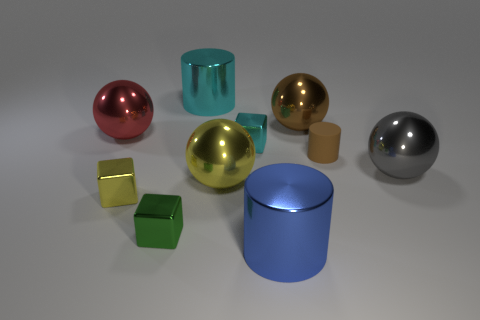Subtract all cyan metal cylinders. How many cylinders are left? 2 Subtract all green cubes. How many cubes are left? 2 Subtract 2 balls. How many balls are left? 2 Subtract 1 yellow spheres. How many objects are left? 9 Subtract all cubes. How many objects are left? 7 Subtract all brown cubes. Subtract all cyan spheres. How many cubes are left? 3 Subtract all big blue cylinders. Subtract all cylinders. How many objects are left? 6 Add 9 gray balls. How many gray balls are left? 10 Add 9 big cyan objects. How many big cyan objects exist? 10 